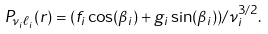Convert formula to latex. <formula><loc_0><loc_0><loc_500><loc_500>P _ { \nu _ { i } \ell _ { i } } ( r ) = ( f _ { i } \cos ( \beta _ { i } ) + g _ { i } \sin ( \beta _ { i } ) ) / \nu _ { i } ^ { 3 / 2 } .</formula> 